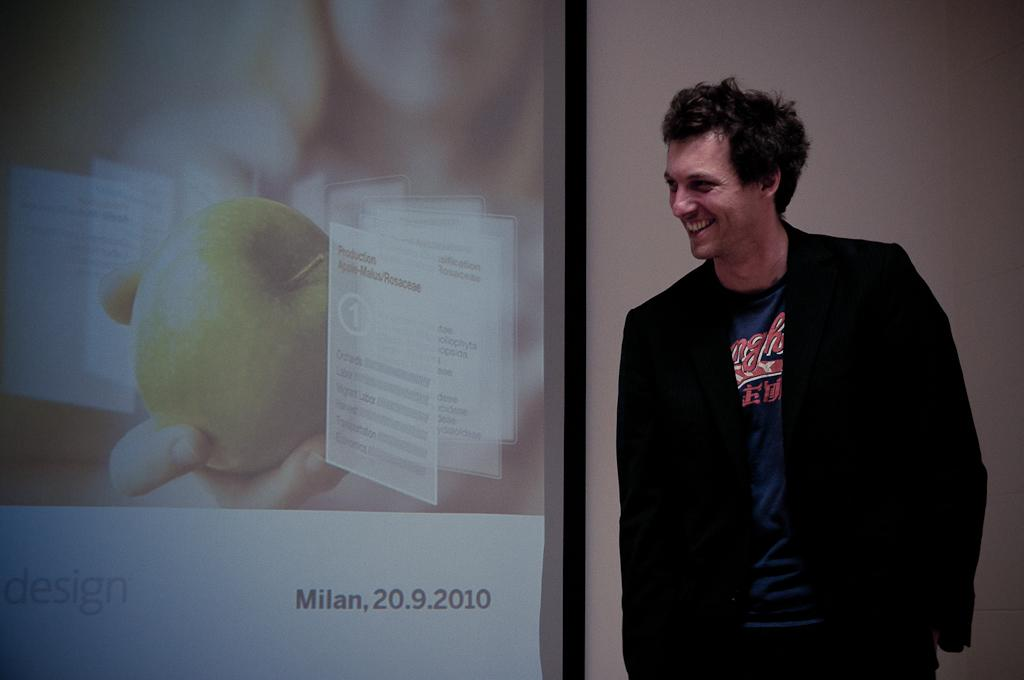<image>
Describe the image concisely. the year 2010 is on the screen next to the man 